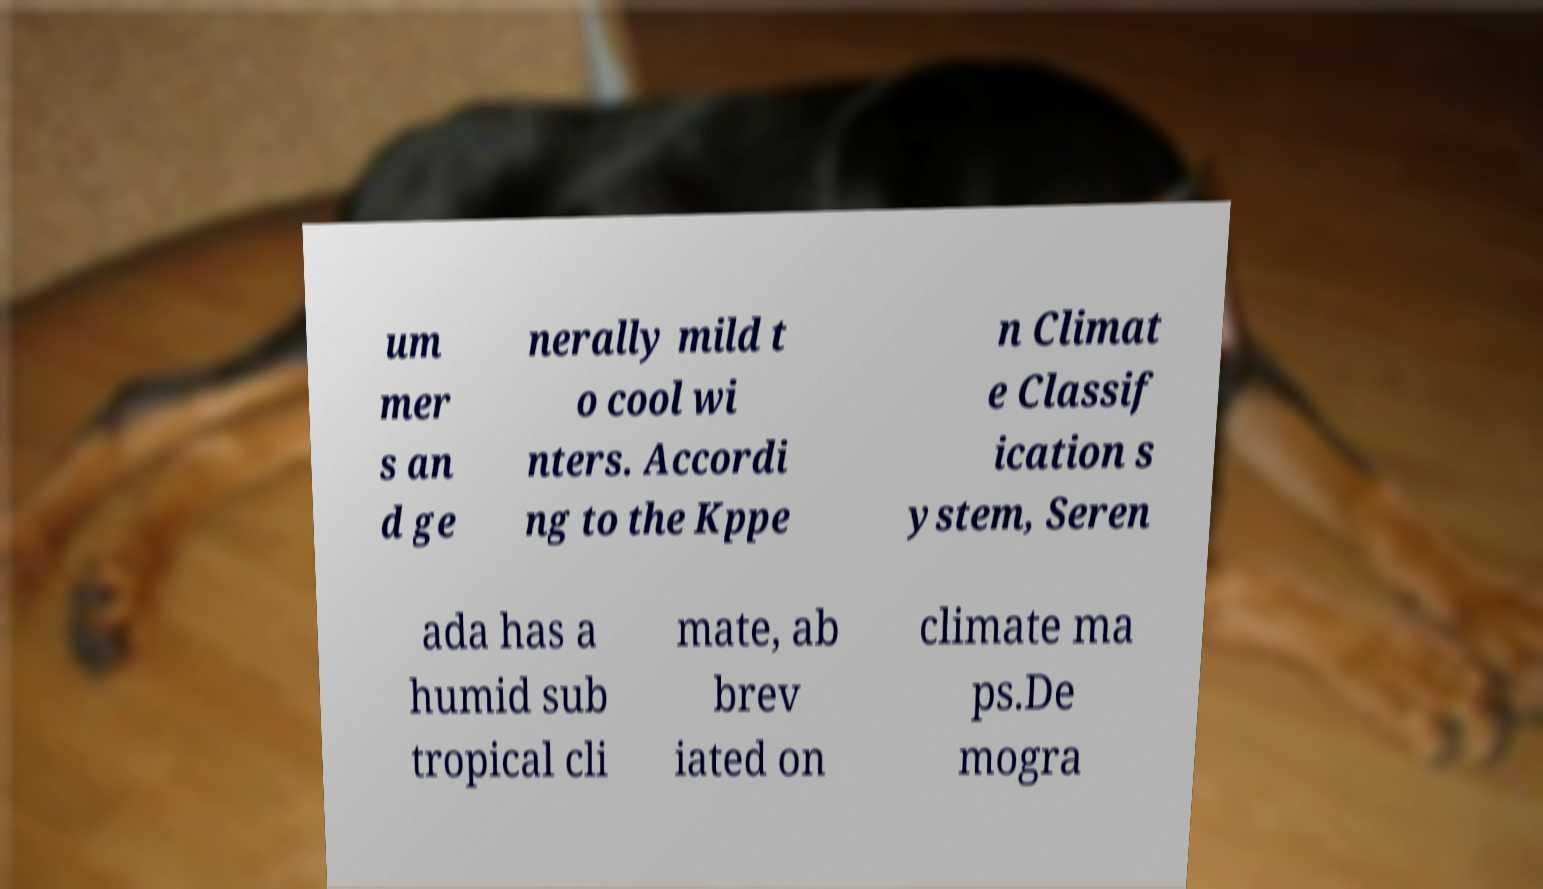Please identify and transcribe the text found in this image. um mer s an d ge nerally mild t o cool wi nters. Accordi ng to the Kppe n Climat e Classif ication s ystem, Seren ada has a humid sub tropical cli mate, ab brev iated on climate ma ps.De mogra 